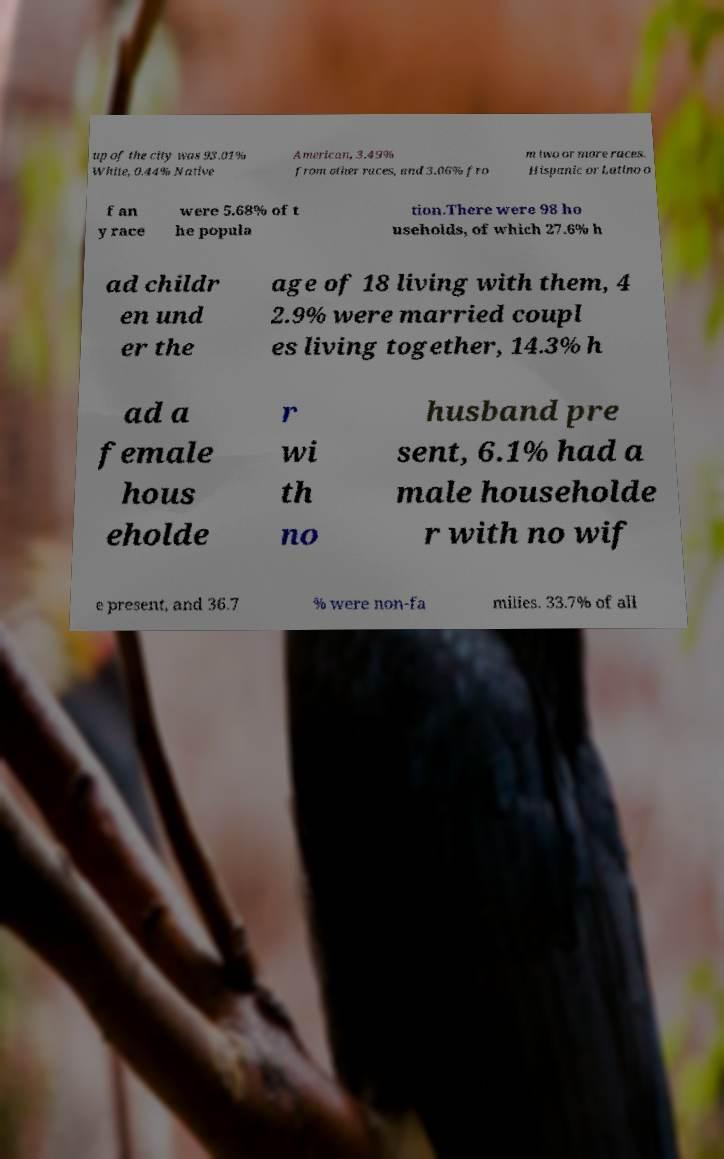Could you extract and type out the text from this image? up of the city was 93.01% White, 0.44% Native American, 3.49% from other races, and 3.06% fro m two or more races. Hispanic or Latino o f an y race were 5.68% of t he popula tion.There were 98 ho useholds, of which 27.6% h ad childr en und er the age of 18 living with them, 4 2.9% were married coupl es living together, 14.3% h ad a female hous eholde r wi th no husband pre sent, 6.1% had a male householde r with no wif e present, and 36.7 % were non-fa milies. 33.7% of all 